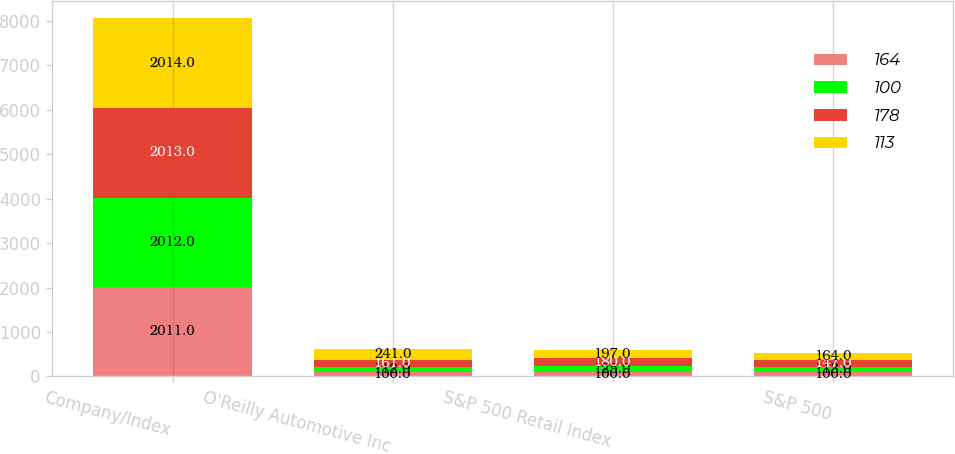Convert chart to OTSL. <chart><loc_0><loc_0><loc_500><loc_500><stacked_bar_chart><ecel><fcel>Company/Index<fcel>O'Reilly Automotive Inc<fcel>S&P 500 Retail Index<fcel>S&P 500<nl><fcel>164<fcel>2011<fcel>100<fcel>100<fcel>100<nl><fcel>100<fcel>2012<fcel>112<fcel>125<fcel>113<nl><fcel>178<fcel>2013<fcel>161<fcel>180<fcel>147<nl><fcel>113<fcel>2014<fcel>241<fcel>197<fcel>164<nl></chart> 